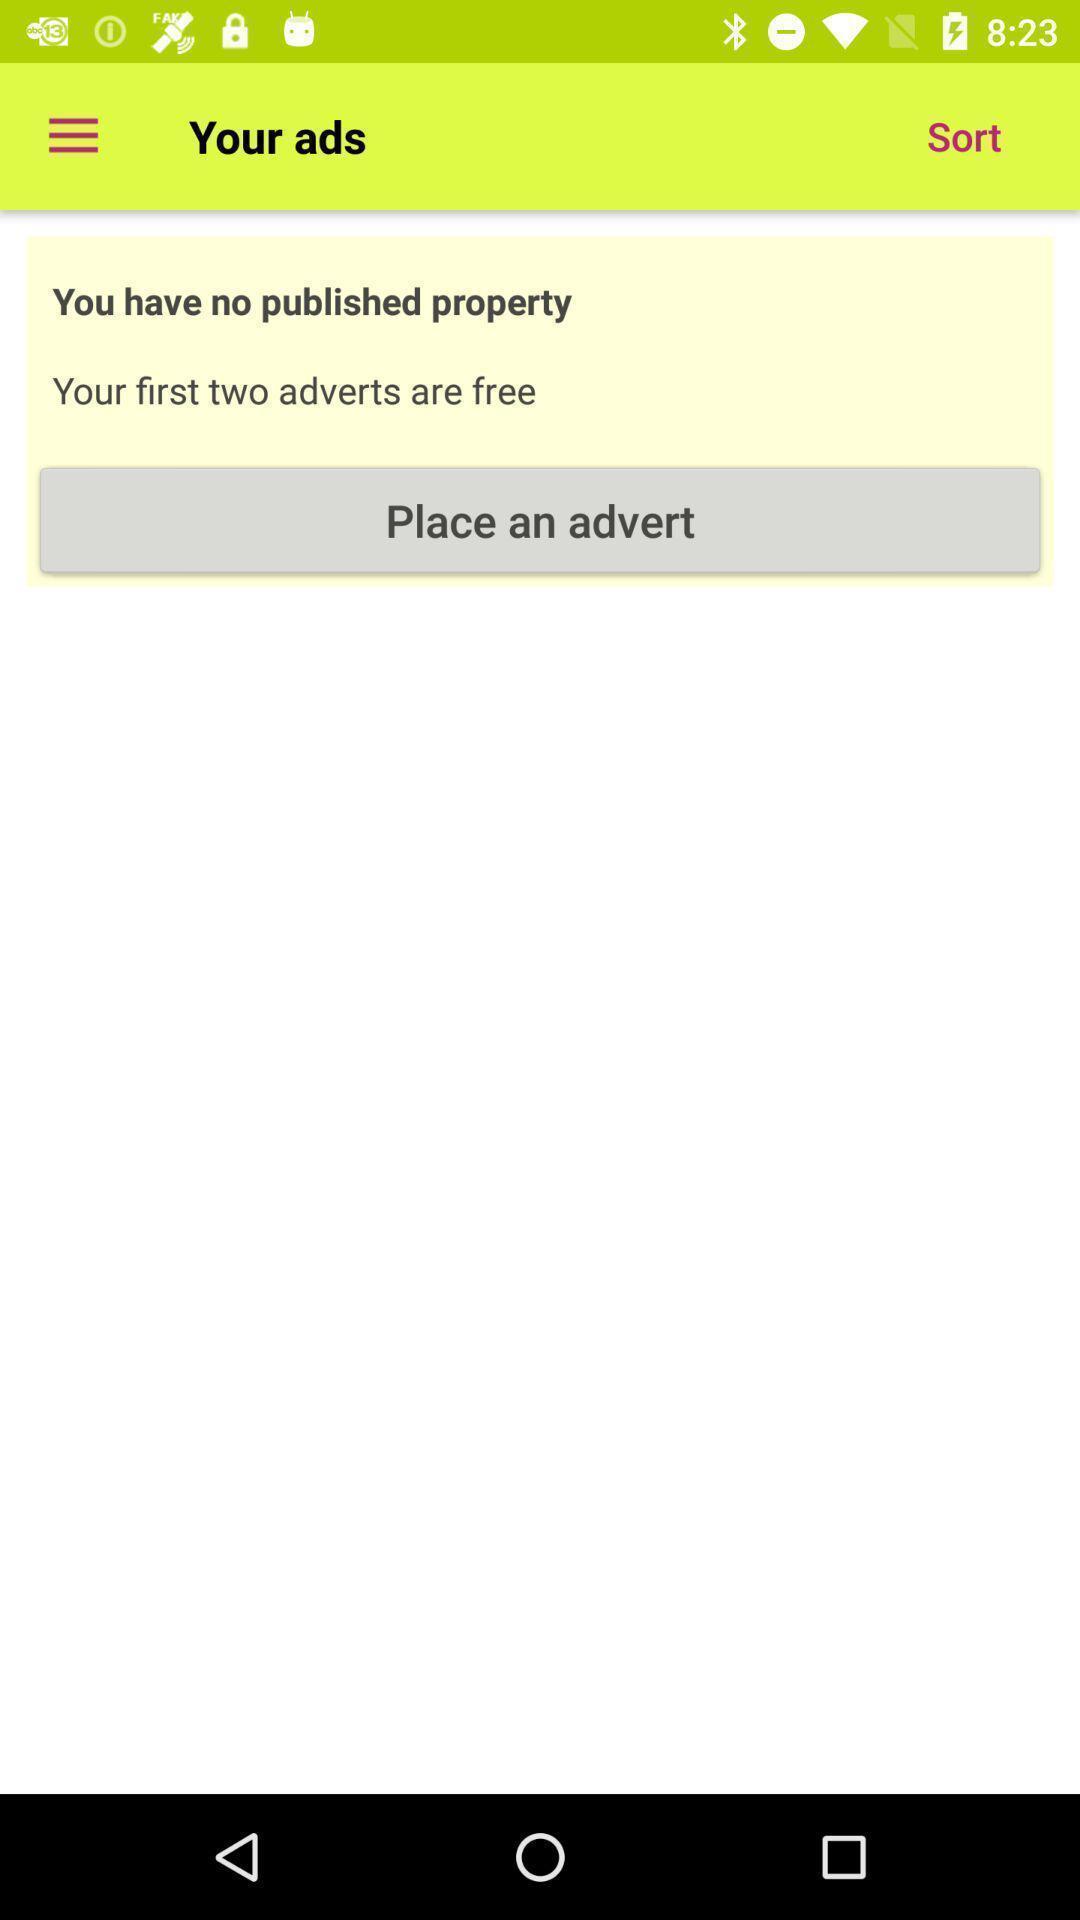Describe the content in this image. Screen shows your ads details in an property app. 